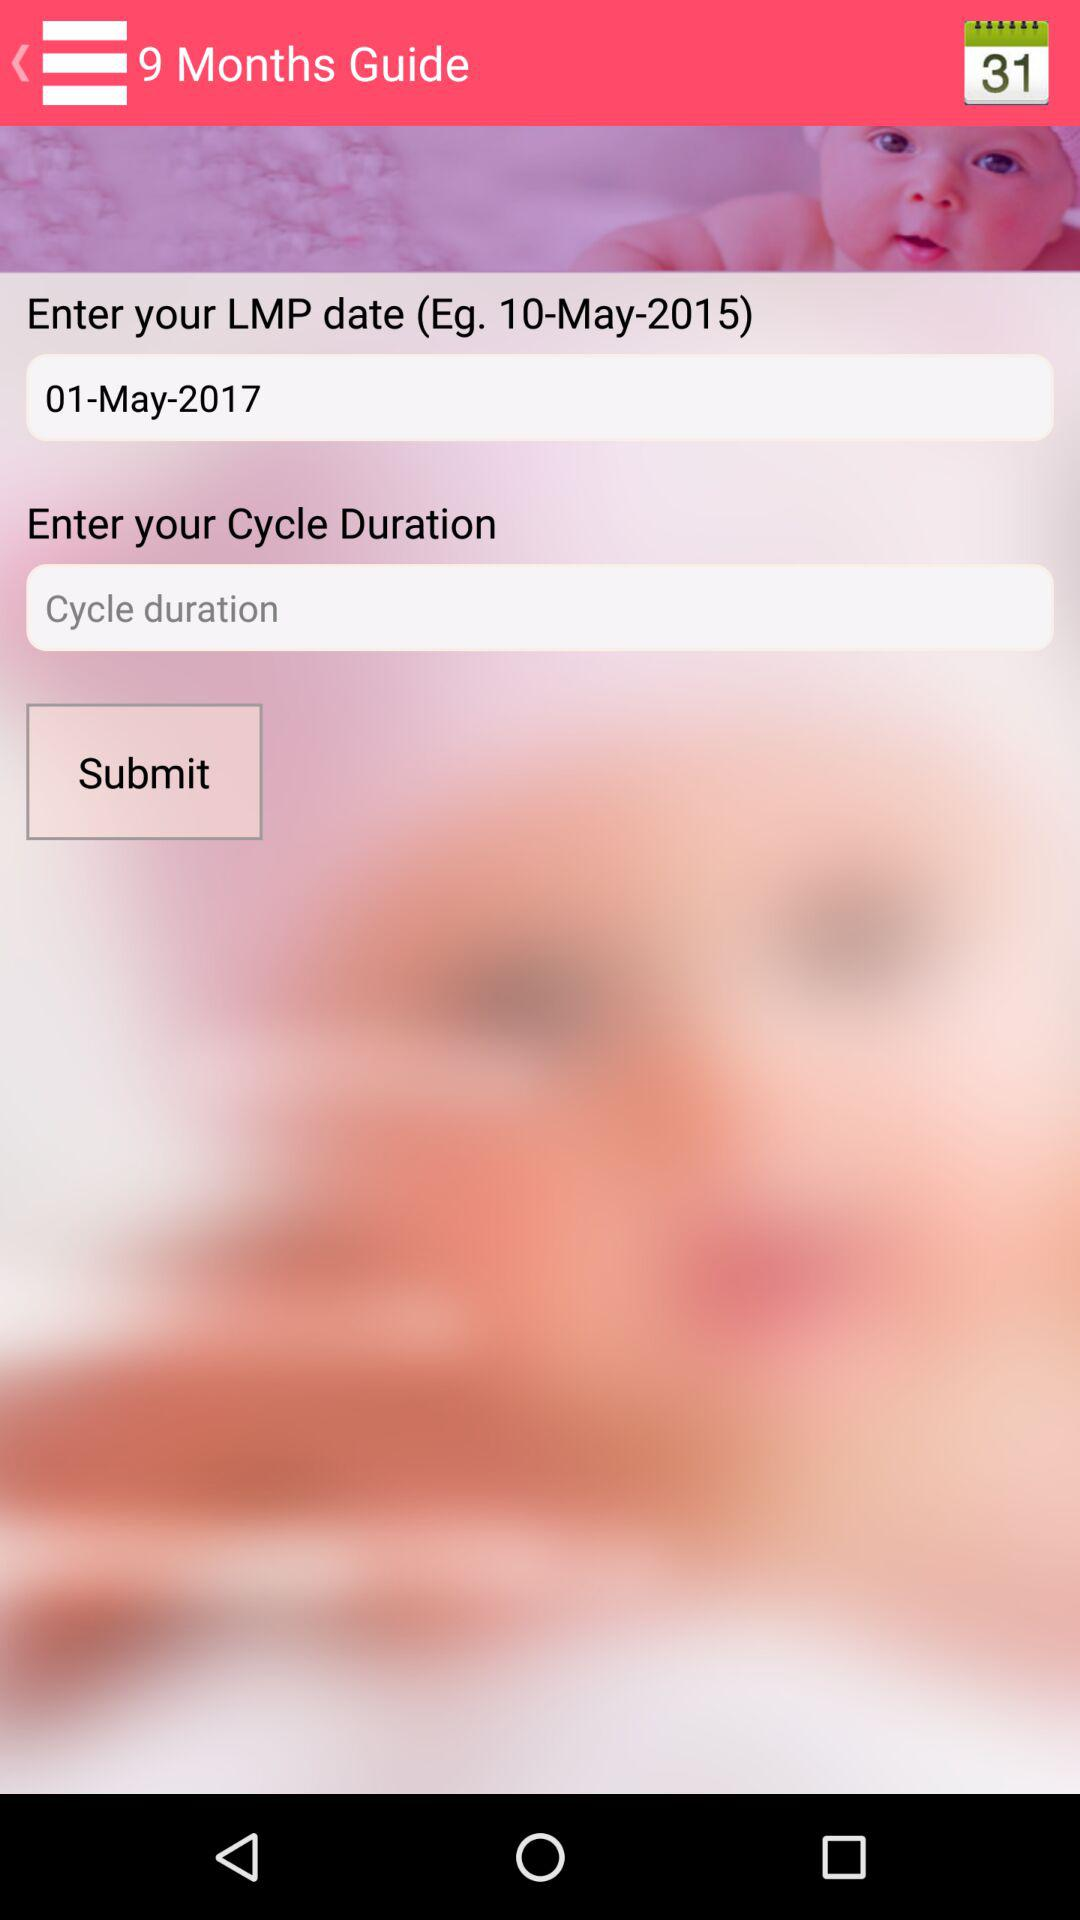How many guide months are there?
When the provided information is insufficient, respond with <no answer>. <no answer> 